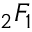<formula> <loc_0><loc_0><loc_500><loc_500>{ } _ { 2 } F _ { 1 }</formula> 